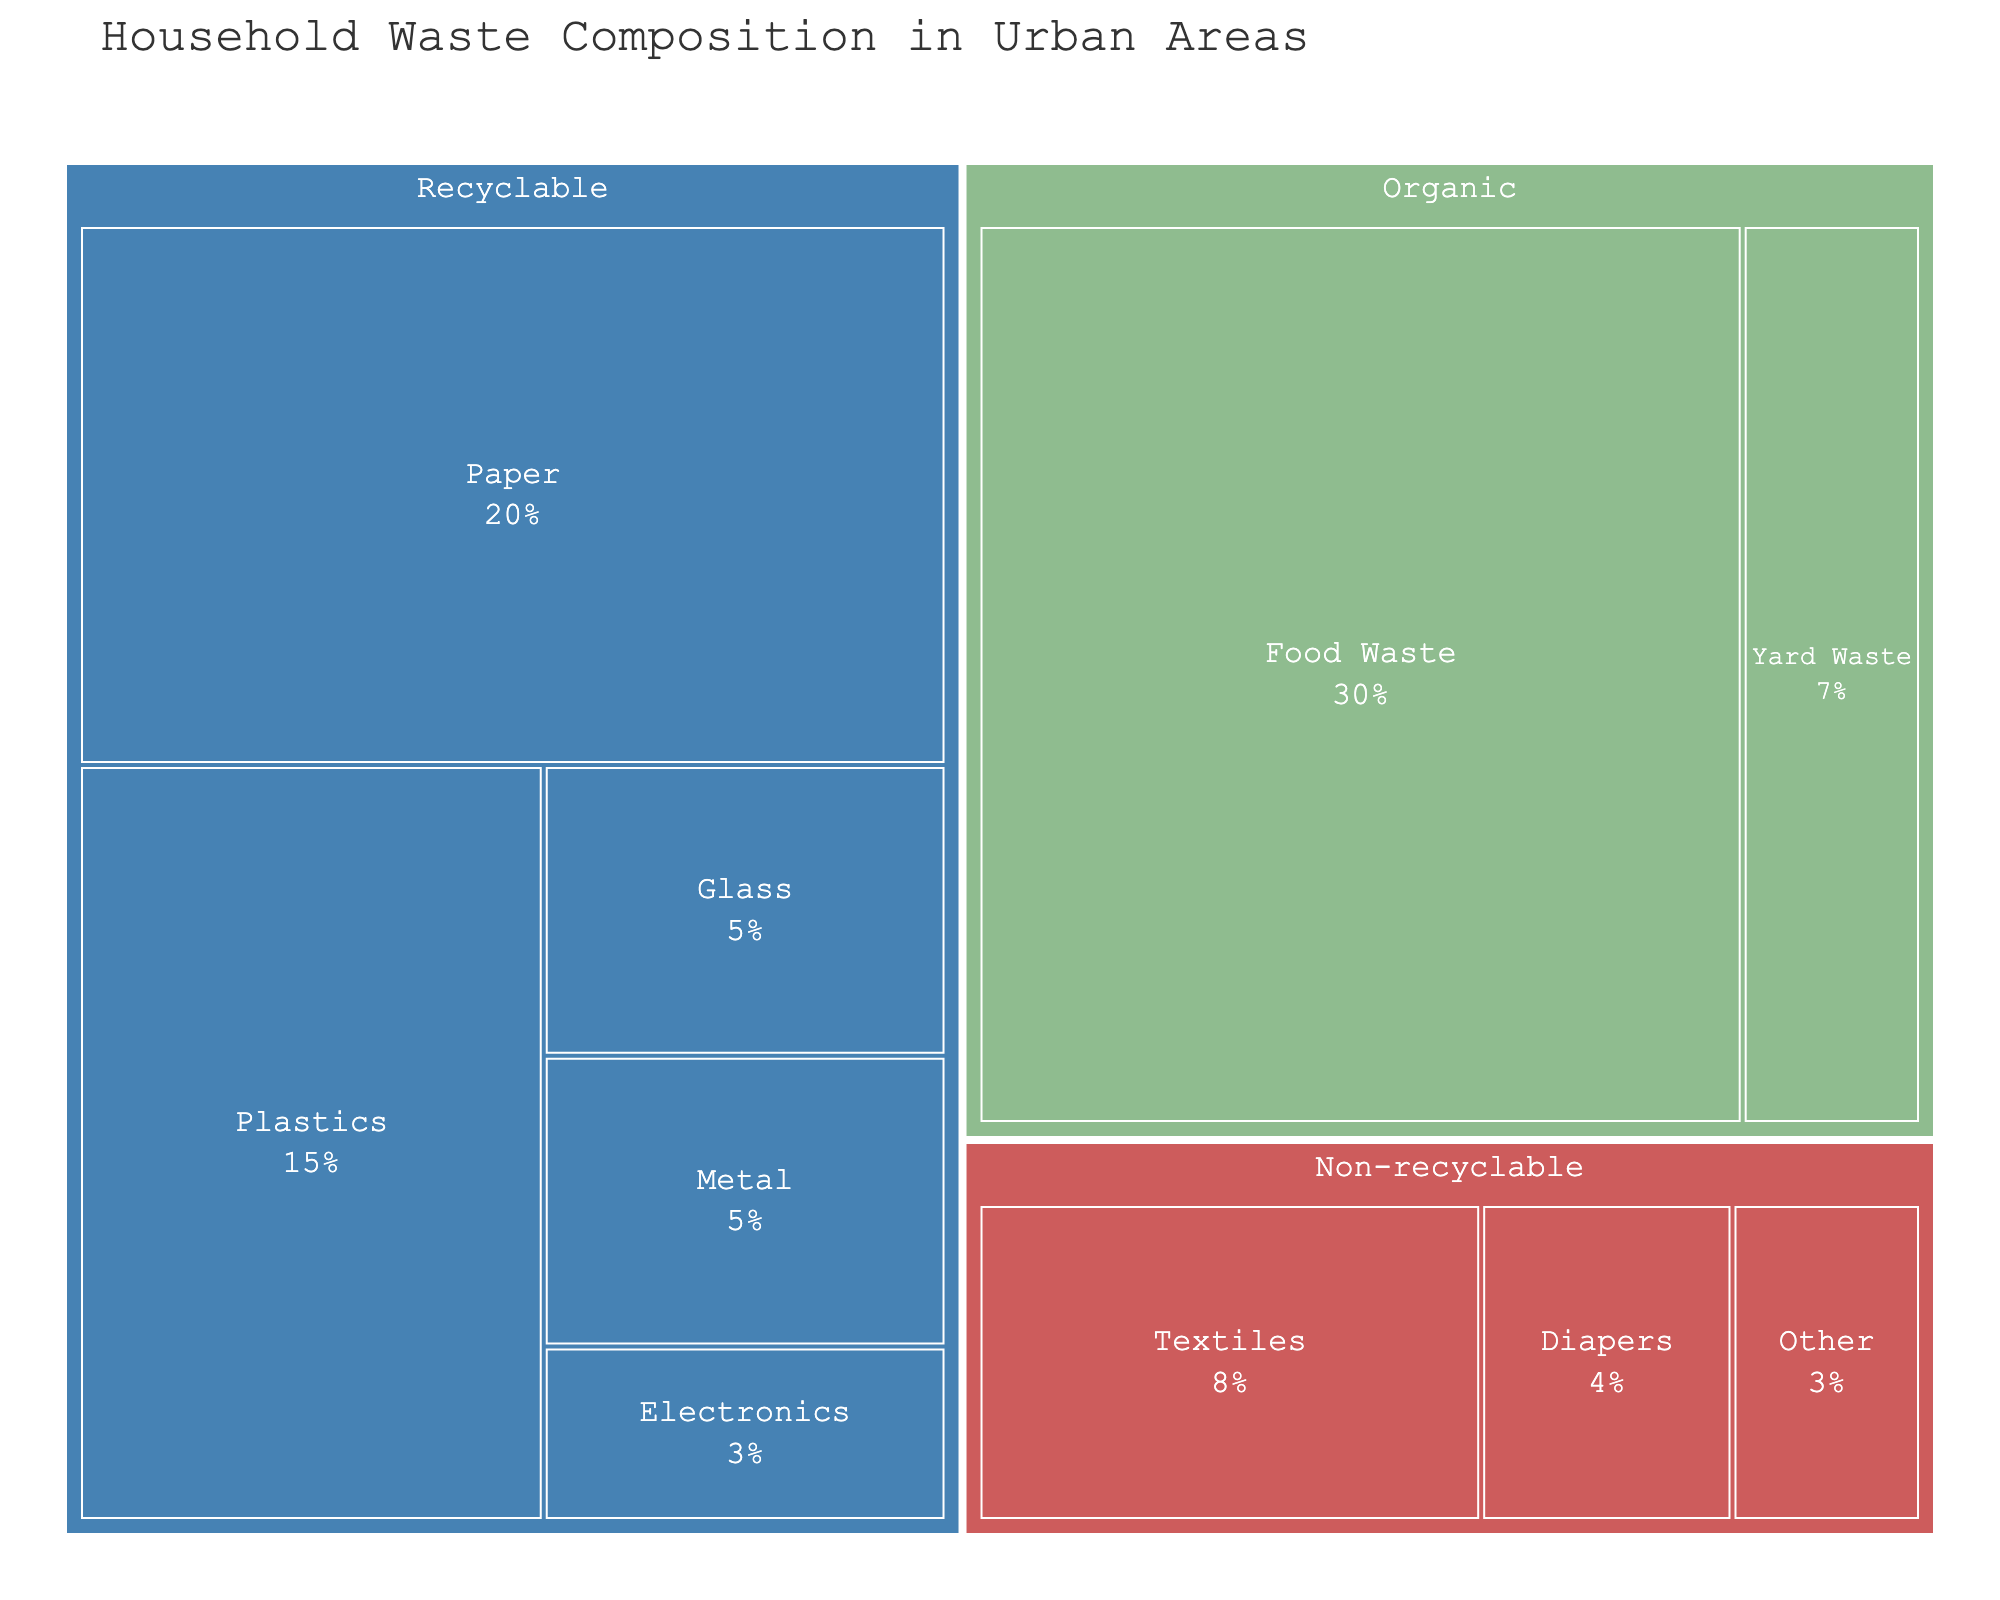How much percentage of household waste belongs to the 'Organic' category? Look at the 'Organic' section on the treemap and sum up the percentages of 'Food Waste' (30%) and 'Yard Waste' (7%)
Answer: 37% What material type in the 'Recyclable' category occupies the largest percentage? Check the 'Recyclable' section, then identify which material type has the highest percentage. 'Paper' has the highest at 20%
Answer: Paper What is the total percentage of recyclable waste? Sum up the percentages of all recyclable materials: 'Paper' (20%), 'Plastics' (15%), 'Glass' (5%), 'Metal' (5%), and 'Electronics' (3%). Total is 20% + 15% + 5% + 5% + 3% = 48%
Answer: 48% Which category has the smallest total percentage in the household waste composition? Compare the summed percentages of all categories: 'Organic' (37%), 'Recyclable' (48%), and 'Non-recyclable' (15%). 'Non-recyclable' is the smallest
Answer: Non-recyclable How does the percentage of 'Diapers' compare to 'Yard Waste'? Look at the percentages for 'Diapers' (4%) and 'Yard Waste' (7%). Compare them. 4% is less than 7%
Answer: Less What is the combined percentage of 'Textiles' and 'Other' in the 'Non-recyclable' category? Add 'Textiles' (8%) and 'Other' (3%) percentages together. 8% + 3% = 11%
Answer: 11% Which is greater: the total percentage of 'Organic' waste or the percentage of 'Recyclable' plastics? Compare the total 'Organic' percentage (37%) with 'Plastics' (15%). 37% is greater than 15%
Answer: Organic waste What percentage of household waste is 'Electronics'? Simply look at the 'Electronics' percentage in the 'Recyclable' category. It's 3%
Answer: 3% What is the percentage difference between 'Food Waste' and 'Paper'? Subtract the percentage of 'Paper' (20%) from 'Food Waste' (30%). 30% - 20% = 10%
Answer: 10% How many categories are defined in the treemap? Identify and count the distinct categories: 'Organic,' 'Recyclable,' and 'Non-recyclable'. There are 3
Answer: 3 